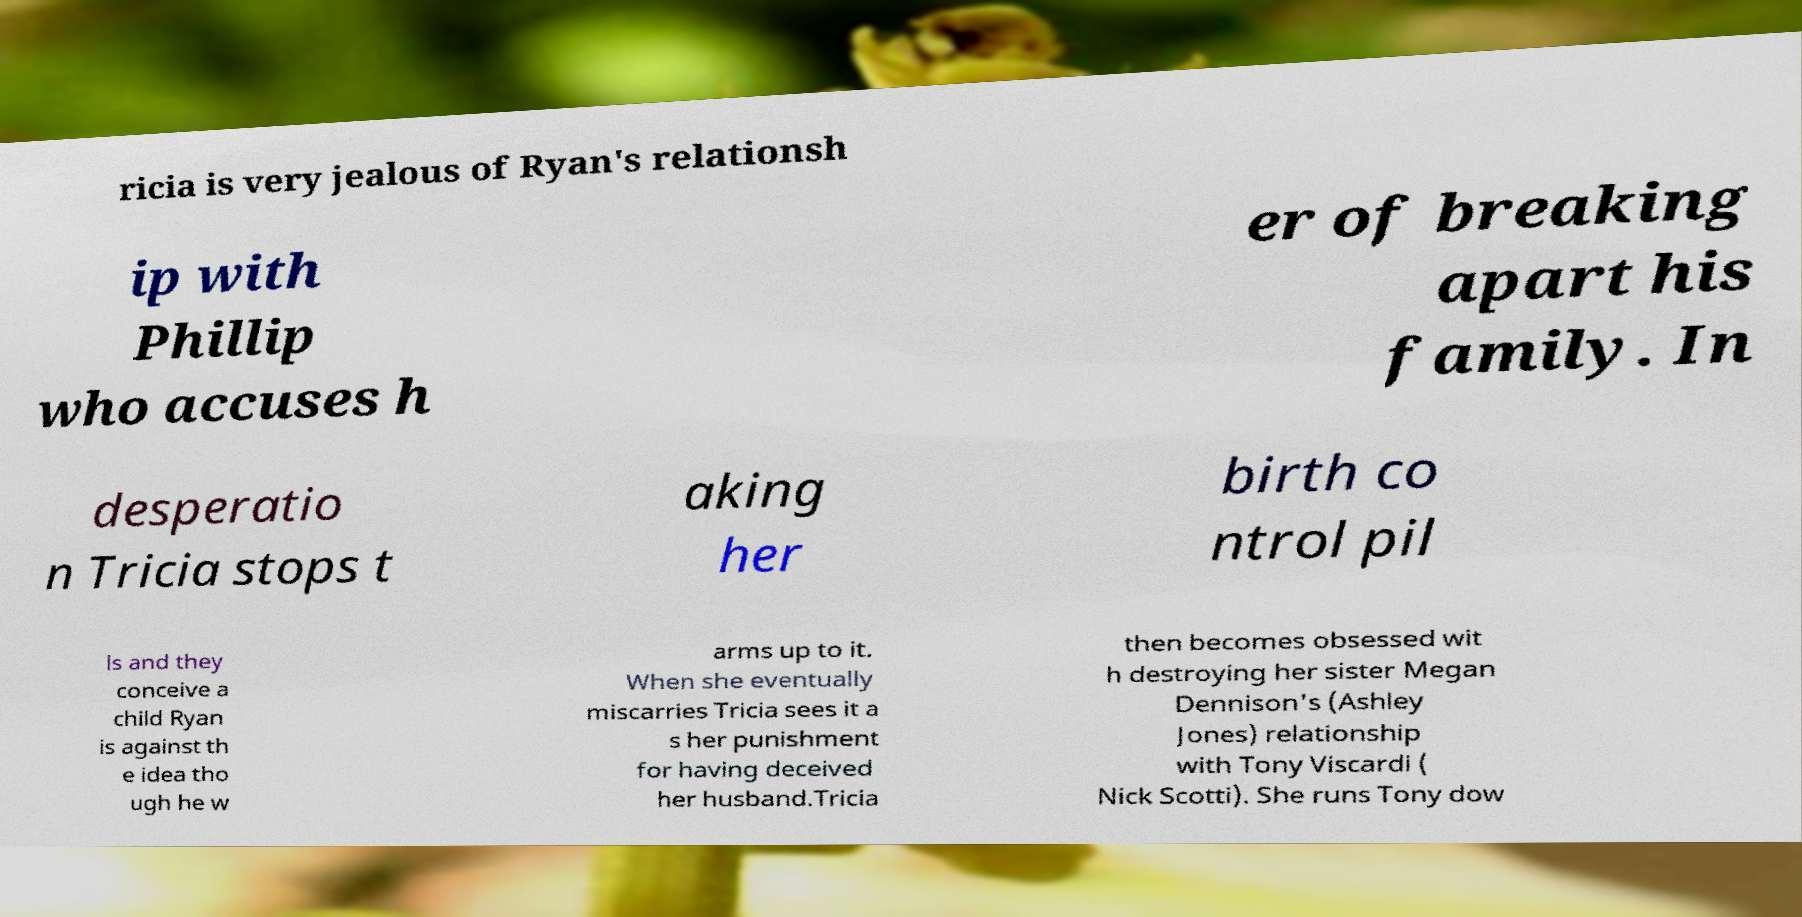I need the written content from this picture converted into text. Can you do that? ricia is very jealous of Ryan's relationsh ip with Phillip who accuses h er of breaking apart his family. In desperatio n Tricia stops t aking her birth co ntrol pil ls and they conceive a child Ryan is against th e idea tho ugh he w arms up to it. When she eventually miscarries Tricia sees it a s her punishment for having deceived her husband.Tricia then becomes obsessed wit h destroying her sister Megan Dennison's (Ashley Jones) relationship with Tony Viscardi ( Nick Scotti). She runs Tony dow 